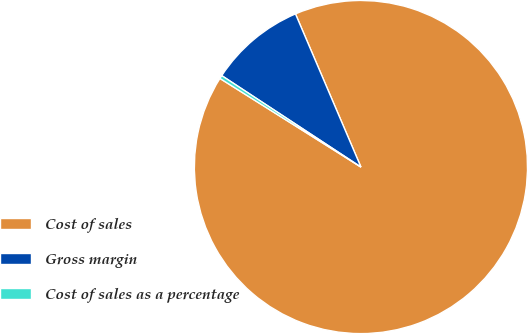Convert chart to OTSL. <chart><loc_0><loc_0><loc_500><loc_500><pie_chart><fcel>Cost of sales<fcel>Gross margin<fcel>Cost of sales as a percentage<nl><fcel>90.36%<fcel>9.32%<fcel>0.32%<nl></chart> 